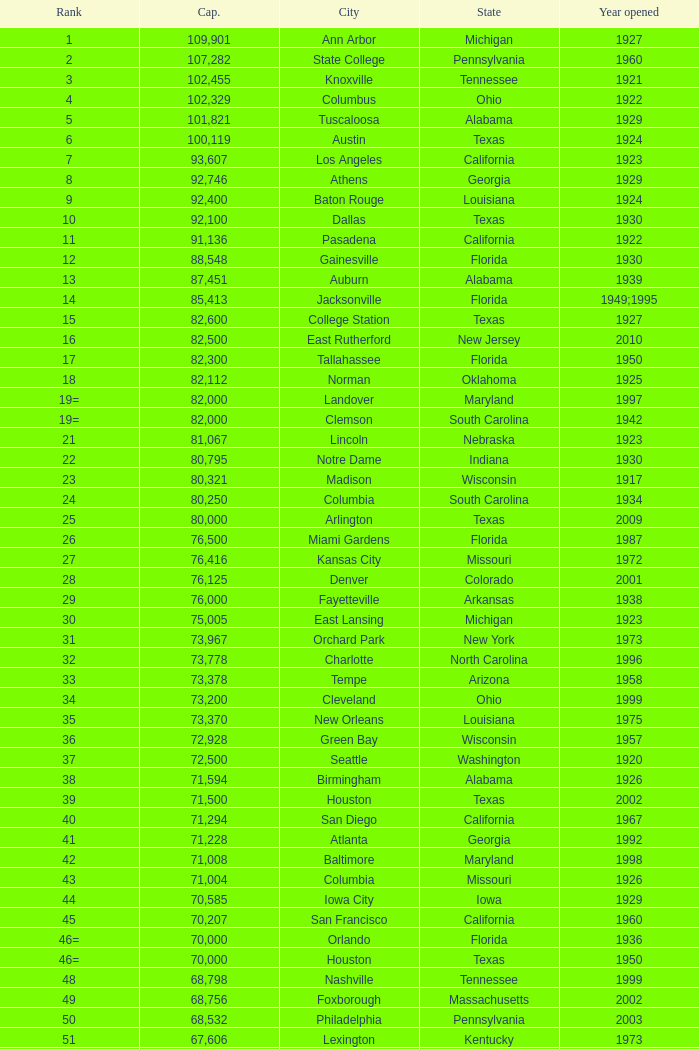What was the year opened for North Carolina with a smaller than 21,500 capacity? 1926.0. 